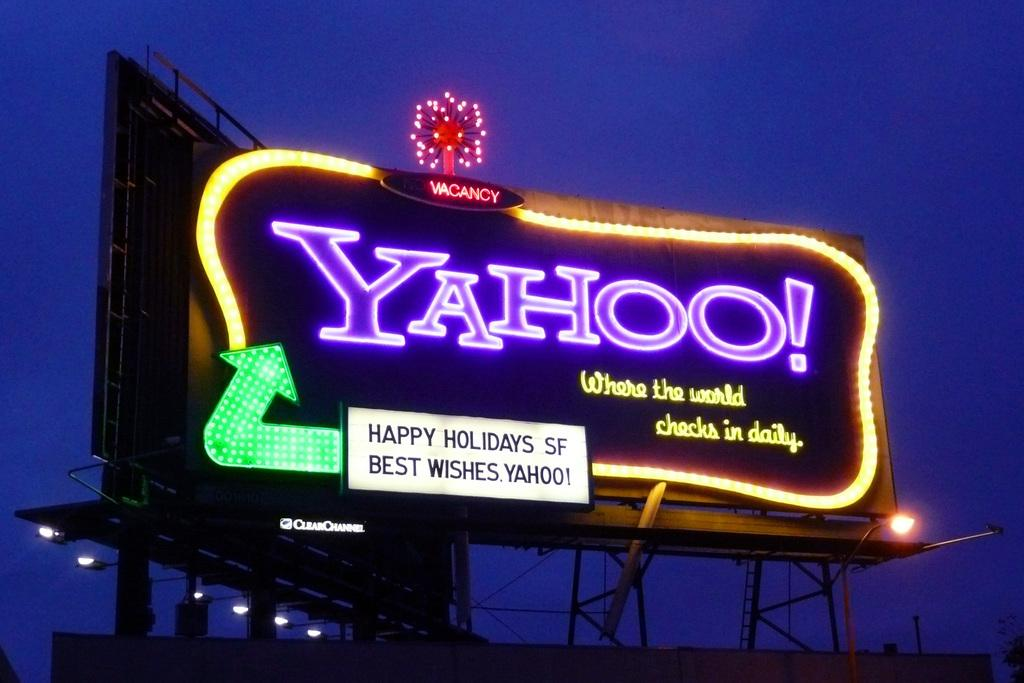<image>
Describe the image concisely. A large lighted sign advertises Yahoo and has a green arrow on it. 